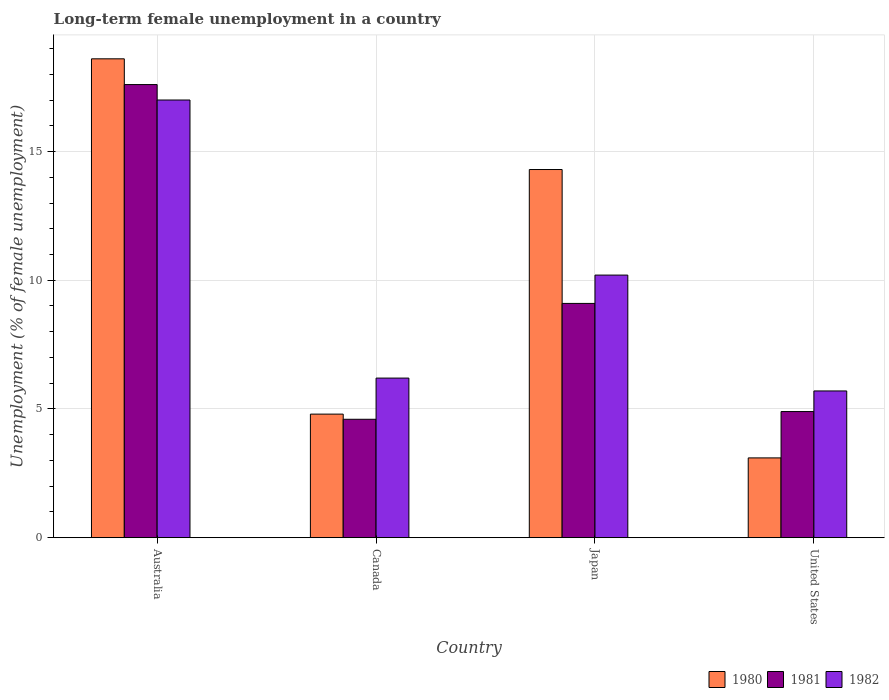How many different coloured bars are there?
Your response must be concise. 3. How many groups of bars are there?
Make the answer very short. 4. Are the number of bars per tick equal to the number of legend labels?
Provide a succinct answer. Yes. In how many cases, is the number of bars for a given country not equal to the number of legend labels?
Give a very brief answer. 0. What is the percentage of long-term unemployed female population in 1980 in Canada?
Keep it short and to the point. 4.8. Across all countries, what is the maximum percentage of long-term unemployed female population in 1982?
Provide a short and direct response. 17. Across all countries, what is the minimum percentage of long-term unemployed female population in 1982?
Give a very brief answer. 5.7. In which country was the percentage of long-term unemployed female population in 1982 maximum?
Give a very brief answer. Australia. In which country was the percentage of long-term unemployed female population in 1980 minimum?
Keep it short and to the point. United States. What is the total percentage of long-term unemployed female population in 1981 in the graph?
Offer a very short reply. 36.2. What is the difference between the percentage of long-term unemployed female population in 1980 in Australia and that in United States?
Your answer should be very brief. 15.5. What is the difference between the percentage of long-term unemployed female population in 1982 in Australia and the percentage of long-term unemployed female population in 1980 in United States?
Offer a very short reply. 13.9. What is the average percentage of long-term unemployed female population in 1982 per country?
Your answer should be very brief. 9.77. What is the difference between the percentage of long-term unemployed female population of/in 1982 and percentage of long-term unemployed female population of/in 1980 in Canada?
Your response must be concise. 1.4. In how many countries, is the percentage of long-term unemployed female population in 1981 greater than 2 %?
Your response must be concise. 4. What is the ratio of the percentage of long-term unemployed female population in 1982 in Canada to that in United States?
Keep it short and to the point. 1.09. Is the percentage of long-term unemployed female population in 1981 in Australia less than that in Japan?
Your response must be concise. No. Is the difference between the percentage of long-term unemployed female population in 1982 in Australia and Canada greater than the difference between the percentage of long-term unemployed female population in 1980 in Australia and Canada?
Your answer should be compact. No. What is the difference between the highest and the second highest percentage of long-term unemployed female population in 1981?
Provide a short and direct response. 12.7. What is the difference between the highest and the lowest percentage of long-term unemployed female population in 1980?
Your answer should be compact. 15.5. Is the sum of the percentage of long-term unemployed female population in 1980 in Canada and United States greater than the maximum percentage of long-term unemployed female population in 1982 across all countries?
Make the answer very short. No. What does the 1st bar from the left in United States represents?
Provide a succinct answer. 1980. What does the 3rd bar from the right in Australia represents?
Offer a terse response. 1980. What is the difference between two consecutive major ticks on the Y-axis?
Give a very brief answer. 5. Are the values on the major ticks of Y-axis written in scientific E-notation?
Make the answer very short. No. Does the graph contain grids?
Provide a short and direct response. Yes. Where does the legend appear in the graph?
Offer a terse response. Bottom right. How many legend labels are there?
Provide a succinct answer. 3. What is the title of the graph?
Provide a short and direct response. Long-term female unemployment in a country. Does "1960" appear as one of the legend labels in the graph?
Keep it short and to the point. No. What is the label or title of the Y-axis?
Provide a short and direct response. Unemployment (% of female unemployment). What is the Unemployment (% of female unemployment) in 1980 in Australia?
Your answer should be very brief. 18.6. What is the Unemployment (% of female unemployment) of 1981 in Australia?
Ensure brevity in your answer.  17.6. What is the Unemployment (% of female unemployment) of 1982 in Australia?
Your answer should be very brief. 17. What is the Unemployment (% of female unemployment) of 1980 in Canada?
Make the answer very short. 4.8. What is the Unemployment (% of female unemployment) of 1981 in Canada?
Make the answer very short. 4.6. What is the Unemployment (% of female unemployment) of 1982 in Canada?
Your answer should be compact. 6.2. What is the Unemployment (% of female unemployment) in 1980 in Japan?
Ensure brevity in your answer.  14.3. What is the Unemployment (% of female unemployment) of 1981 in Japan?
Provide a succinct answer. 9.1. What is the Unemployment (% of female unemployment) of 1982 in Japan?
Your answer should be very brief. 10.2. What is the Unemployment (% of female unemployment) of 1980 in United States?
Make the answer very short. 3.1. What is the Unemployment (% of female unemployment) in 1981 in United States?
Ensure brevity in your answer.  4.9. What is the Unemployment (% of female unemployment) of 1982 in United States?
Your response must be concise. 5.7. Across all countries, what is the maximum Unemployment (% of female unemployment) in 1980?
Provide a succinct answer. 18.6. Across all countries, what is the maximum Unemployment (% of female unemployment) of 1981?
Offer a very short reply. 17.6. Across all countries, what is the maximum Unemployment (% of female unemployment) in 1982?
Your answer should be compact. 17. Across all countries, what is the minimum Unemployment (% of female unemployment) in 1980?
Make the answer very short. 3.1. Across all countries, what is the minimum Unemployment (% of female unemployment) of 1981?
Offer a terse response. 4.6. Across all countries, what is the minimum Unemployment (% of female unemployment) of 1982?
Your answer should be compact. 5.7. What is the total Unemployment (% of female unemployment) in 1980 in the graph?
Your answer should be compact. 40.8. What is the total Unemployment (% of female unemployment) of 1981 in the graph?
Offer a terse response. 36.2. What is the total Unemployment (% of female unemployment) of 1982 in the graph?
Your answer should be compact. 39.1. What is the difference between the Unemployment (% of female unemployment) of 1980 in Australia and that in Canada?
Ensure brevity in your answer.  13.8. What is the difference between the Unemployment (% of female unemployment) of 1981 in Australia and that in Canada?
Make the answer very short. 13. What is the difference between the Unemployment (% of female unemployment) in 1982 in Australia and that in Canada?
Your answer should be very brief. 10.8. What is the difference between the Unemployment (% of female unemployment) in 1981 in Australia and that in Japan?
Offer a terse response. 8.5. What is the difference between the Unemployment (% of female unemployment) in 1981 in Australia and that in United States?
Keep it short and to the point. 12.7. What is the difference between the Unemployment (% of female unemployment) of 1980 in Canada and that in Japan?
Your response must be concise. -9.5. What is the difference between the Unemployment (% of female unemployment) in 1982 in Canada and that in Japan?
Provide a succinct answer. -4. What is the difference between the Unemployment (% of female unemployment) in 1981 in Canada and that in United States?
Give a very brief answer. -0.3. What is the difference between the Unemployment (% of female unemployment) in 1982 in Canada and that in United States?
Give a very brief answer. 0.5. What is the difference between the Unemployment (% of female unemployment) of 1980 in Japan and that in United States?
Keep it short and to the point. 11.2. What is the difference between the Unemployment (% of female unemployment) of 1981 in Australia and the Unemployment (% of female unemployment) of 1982 in Canada?
Offer a terse response. 11.4. What is the difference between the Unemployment (% of female unemployment) in 1980 in Australia and the Unemployment (% of female unemployment) in 1982 in Japan?
Your answer should be very brief. 8.4. What is the difference between the Unemployment (% of female unemployment) of 1981 in Australia and the Unemployment (% of female unemployment) of 1982 in Japan?
Your response must be concise. 7.4. What is the difference between the Unemployment (% of female unemployment) of 1980 in Australia and the Unemployment (% of female unemployment) of 1981 in United States?
Make the answer very short. 13.7. What is the difference between the Unemployment (% of female unemployment) of 1980 in Australia and the Unemployment (% of female unemployment) of 1982 in United States?
Make the answer very short. 12.9. What is the difference between the Unemployment (% of female unemployment) in 1981 in Australia and the Unemployment (% of female unemployment) in 1982 in United States?
Your answer should be very brief. 11.9. What is the difference between the Unemployment (% of female unemployment) in 1981 in Canada and the Unemployment (% of female unemployment) in 1982 in Japan?
Your answer should be compact. -5.6. What is the difference between the Unemployment (% of female unemployment) in 1980 in Canada and the Unemployment (% of female unemployment) in 1981 in United States?
Make the answer very short. -0.1. What is the difference between the Unemployment (% of female unemployment) of 1980 in Japan and the Unemployment (% of female unemployment) of 1981 in United States?
Your answer should be very brief. 9.4. What is the difference between the Unemployment (% of female unemployment) of 1981 in Japan and the Unemployment (% of female unemployment) of 1982 in United States?
Provide a short and direct response. 3.4. What is the average Unemployment (% of female unemployment) of 1981 per country?
Your answer should be compact. 9.05. What is the average Unemployment (% of female unemployment) of 1982 per country?
Offer a very short reply. 9.78. What is the difference between the Unemployment (% of female unemployment) in 1980 and Unemployment (% of female unemployment) in 1982 in Canada?
Give a very brief answer. -1.4. What is the difference between the Unemployment (% of female unemployment) of 1980 and Unemployment (% of female unemployment) of 1981 in Japan?
Your response must be concise. 5.2. What is the ratio of the Unemployment (% of female unemployment) of 1980 in Australia to that in Canada?
Make the answer very short. 3.88. What is the ratio of the Unemployment (% of female unemployment) in 1981 in Australia to that in Canada?
Give a very brief answer. 3.83. What is the ratio of the Unemployment (% of female unemployment) in 1982 in Australia to that in Canada?
Provide a succinct answer. 2.74. What is the ratio of the Unemployment (% of female unemployment) of 1980 in Australia to that in Japan?
Offer a very short reply. 1.3. What is the ratio of the Unemployment (% of female unemployment) in 1981 in Australia to that in Japan?
Your response must be concise. 1.93. What is the ratio of the Unemployment (% of female unemployment) in 1982 in Australia to that in Japan?
Your response must be concise. 1.67. What is the ratio of the Unemployment (% of female unemployment) of 1981 in Australia to that in United States?
Your response must be concise. 3.59. What is the ratio of the Unemployment (% of female unemployment) of 1982 in Australia to that in United States?
Offer a terse response. 2.98. What is the ratio of the Unemployment (% of female unemployment) of 1980 in Canada to that in Japan?
Ensure brevity in your answer.  0.34. What is the ratio of the Unemployment (% of female unemployment) of 1981 in Canada to that in Japan?
Ensure brevity in your answer.  0.51. What is the ratio of the Unemployment (% of female unemployment) in 1982 in Canada to that in Japan?
Your answer should be compact. 0.61. What is the ratio of the Unemployment (% of female unemployment) of 1980 in Canada to that in United States?
Make the answer very short. 1.55. What is the ratio of the Unemployment (% of female unemployment) of 1981 in Canada to that in United States?
Provide a succinct answer. 0.94. What is the ratio of the Unemployment (% of female unemployment) in 1982 in Canada to that in United States?
Keep it short and to the point. 1.09. What is the ratio of the Unemployment (% of female unemployment) of 1980 in Japan to that in United States?
Ensure brevity in your answer.  4.61. What is the ratio of the Unemployment (% of female unemployment) in 1981 in Japan to that in United States?
Provide a short and direct response. 1.86. What is the ratio of the Unemployment (% of female unemployment) of 1982 in Japan to that in United States?
Your answer should be compact. 1.79. What is the difference between the highest and the second highest Unemployment (% of female unemployment) of 1981?
Give a very brief answer. 8.5. 